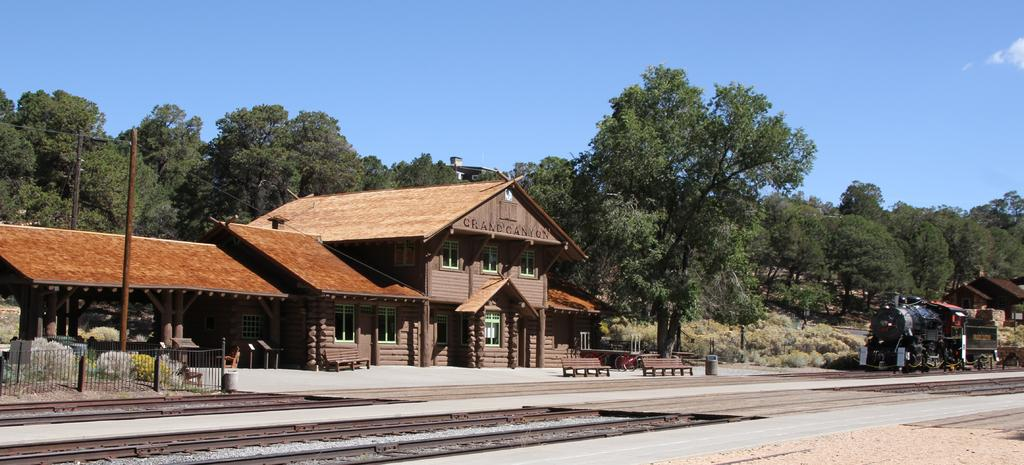What type of structures can be seen in the image? There are houses, an open-shed, and a train engine in the image. What architectural features are present in the image? There are pillars, railing, and benches in the image. What type of transportation is visible in the image? There is a train engine in the image. What natural elements can be seen in the image? There are trees, plants, and the sky visible in the image. What man-made structures are present in the image? There are train tracks, poles, and unspecified objects in the image. What type of ball can be seen bouncing on the train tracks in the image? There is no ball present in the image, and therefore no such activity can be observed. What type of sticks are being used to stir the powder in the image? There is no powder or sticks present in the image. 